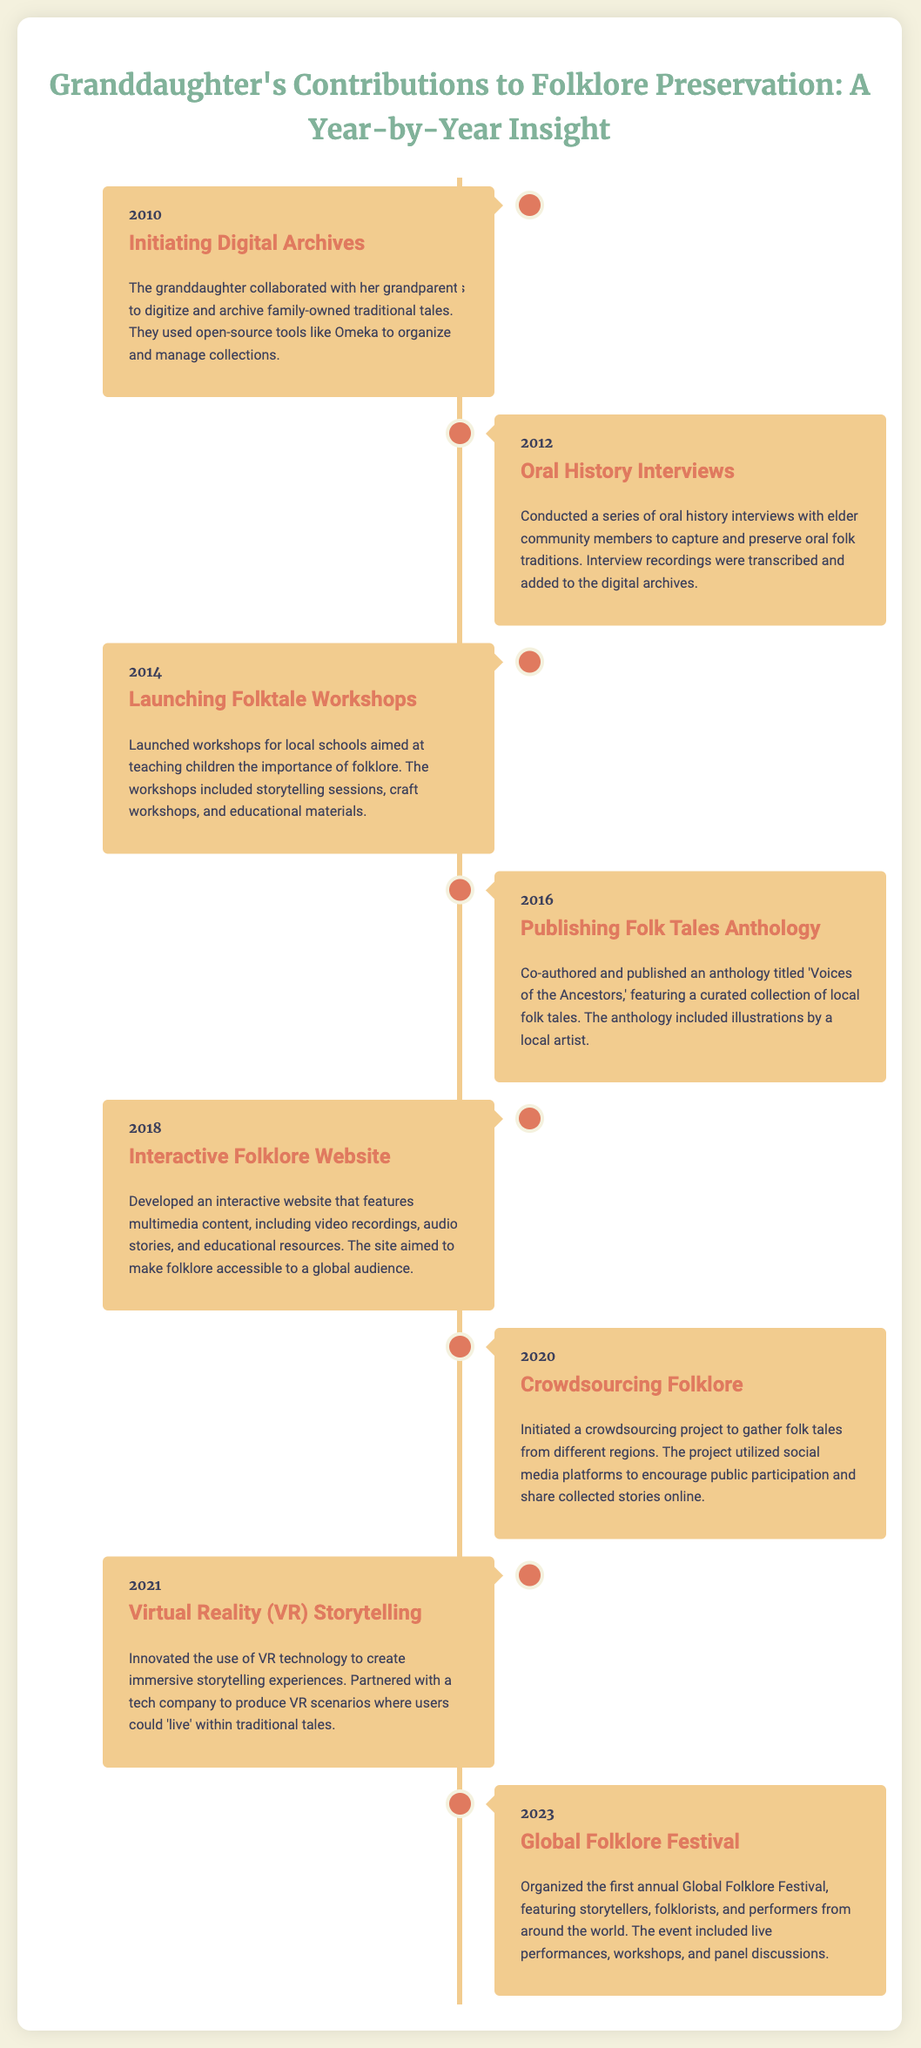What year did the granddaughter initiate digital archives? The document states that the granddaughter began this project in 2010.
Answer: 2010 What is the title of the anthology published in 2016? The title of the anthology published that year is 'Voices of the Ancestors.'
Answer: Voices of the Ancestors In which year were oral history interviews conducted? The timeline indicates that the oral history interviews took place in 2012.
Answer: 2012 What type of technology did the granddaughter use for storytelling in 2021? The document mentions the innovative use of Virtual Reality technology for storytelling.
Answer: Virtual Reality How many years passed between the launching of folktale workshops and the publishing of the anthology? The workshops were launched in 2014 and the anthology was published in 2016, which is two years apart.
Answer: 2 years What major event did the granddaughter organize in 2023? According to the document, she organized the first annual Global Folklore Festival that year.
Answer: Global Folklore Festival What methodology did the granddaughter use in 2020 to gather folk tales? The document specifies that she initiated a crowdsourcing project.
Answer: Crowdsourcing What was the primary audience for the workshops launched in 2014? The workshops were aimed at teaching children the importance of folklore.
Answer: Children 